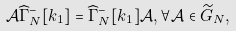<formula> <loc_0><loc_0><loc_500><loc_500>\mathcal { A } \widehat { \Gamma } ^ { - } _ { N } [ k _ { 1 } ] = \widehat { \Gamma } ^ { - } _ { N } [ k _ { 1 } ] \mathcal { A } , \forall \mathcal { A } \in \widetilde { G } _ { N } ,</formula> 